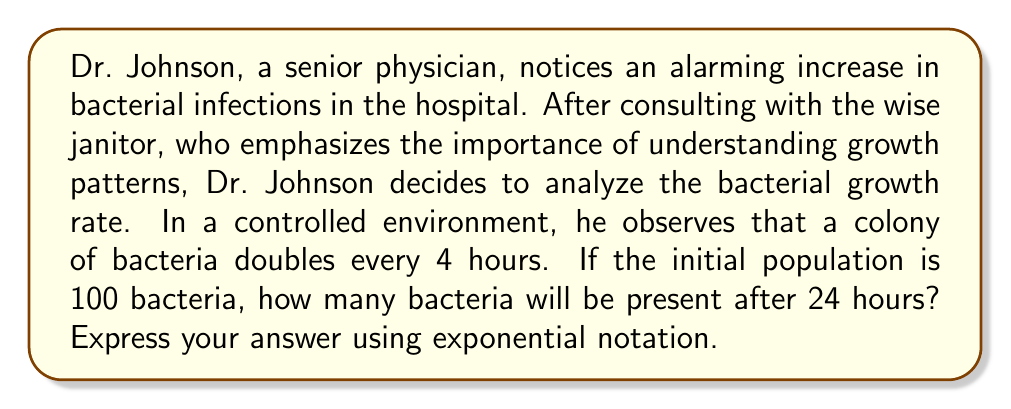Give your solution to this math problem. To solve this problem, we need to use the exponential growth formula:

$$A = A_0 \cdot b^t$$

Where:
$A$ = Final amount
$A_0$ = Initial amount
$b$ = Growth factor per time period
$t$ = Number of time periods

Given:
- Initial population $A_0 = 100$ bacteria
- The population doubles every 4 hours, so $b = 2$
- The time period is 24 hours, which is 6 cycles of 4 hours, so $t = 6$

Let's plug these values into the formula:

$$A = 100 \cdot 2^6$$

To calculate this:
$$\begin{align*}
A &= 100 \cdot 2^6 \\
  &= 100 \cdot 64 \\
  &= 6400
\end{align*}$$

Therefore, after 24 hours, there will be 6400 bacteria.

To express this in exponential notation, we can write:

$$6.4 \times 10^3$$
Answer: $6.4 \times 10^3$ bacteria 